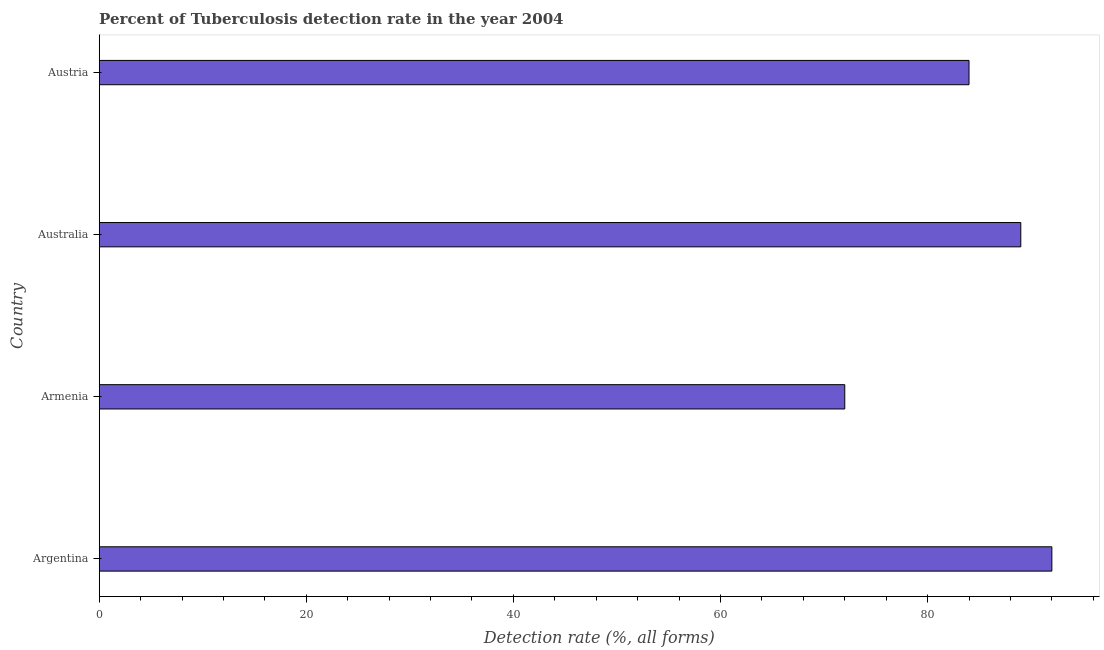Does the graph contain any zero values?
Provide a succinct answer. No. What is the title of the graph?
Provide a short and direct response. Percent of Tuberculosis detection rate in the year 2004. What is the label or title of the X-axis?
Provide a succinct answer. Detection rate (%, all forms). What is the detection rate of tuberculosis in Austria?
Offer a very short reply. 84. Across all countries, what is the maximum detection rate of tuberculosis?
Keep it short and to the point. 92. In which country was the detection rate of tuberculosis minimum?
Your answer should be compact. Armenia. What is the sum of the detection rate of tuberculosis?
Your answer should be compact. 337. What is the difference between the detection rate of tuberculosis in Argentina and Australia?
Your response must be concise. 3. What is the median detection rate of tuberculosis?
Keep it short and to the point. 86.5. What is the ratio of the detection rate of tuberculosis in Armenia to that in Austria?
Your response must be concise. 0.86. Is the detection rate of tuberculosis in Australia less than that in Austria?
Make the answer very short. No. Is the difference between the detection rate of tuberculosis in Australia and Austria greater than the difference between any two countries?
Provide a succinct answer. No. What is the difference between the highest and the second highest detection rate of tuberculosis?
Your response must be concise. 3. What is the difference between the highest and the lowest detection rate of tuberculosis?
Your answer should be compact. 20. In how many countries, is the detection rate of tuberculosis greater than the average detection rate of tuberculosis taken over all countries?
Offer a terse response. 2. How many bars are there?
Keep it short and to the point. 4. Are all the bars in the graph horizontal?
Ensure brevity in your answer.  Yes. What is the Detection rate (%, all forms) in Argentina?
Your answer should be compact. 92. What is the Detection rate (%, all forms) in Australia?
Make the answer very short. 89. What is the Detection rate (%, all forms) in Austria?
Make the answer very short. 84. What is the difference between the Detection rate (%, all forms) in Armenia and Austria?
Provide a succinct answer. -12. What is the ratio of the Detection rate (%, all forms) in Argentina to that in Armenia?
Offer a terse response. 1.28. What is the ratio of the Detection rate (%, all forms) in Argentina to that in Australia?
Provide a succinct answer. 1.03. What is the ratio of the Detection rate (%, all forms) in Argentina to that in Austria?
Offer a terse response. 1.09. What is the ratio of the Detection rate (%, all forms) in Armenia to that in Australia?
Ensure brevity in your answer.  0.81. What is the ratio of the Detection rate (%, all forms) in Armenia to that in Austria?
Your response must be concise. 0.86. What is the ratio of the Detection rate (%, all forms) in Australia to that in Austria?
Make the answer very short. 1.06. 